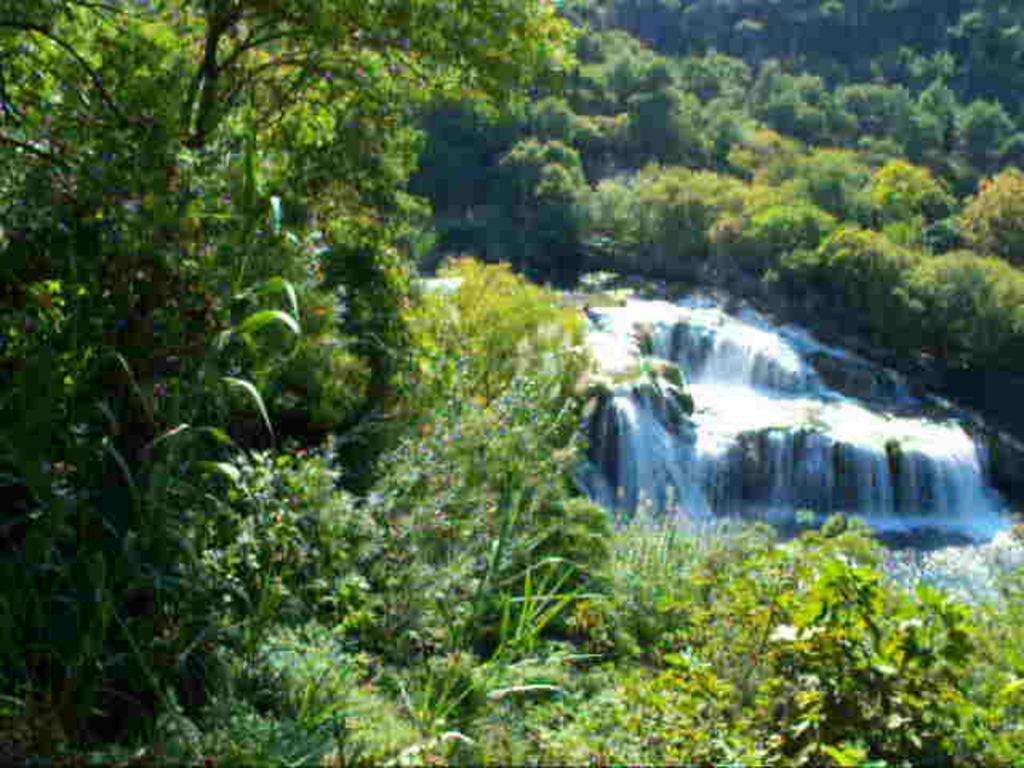Please provide a concise description of this image. In this picture there is waterfall in the center of the image and there is greenery around the area of the image. 